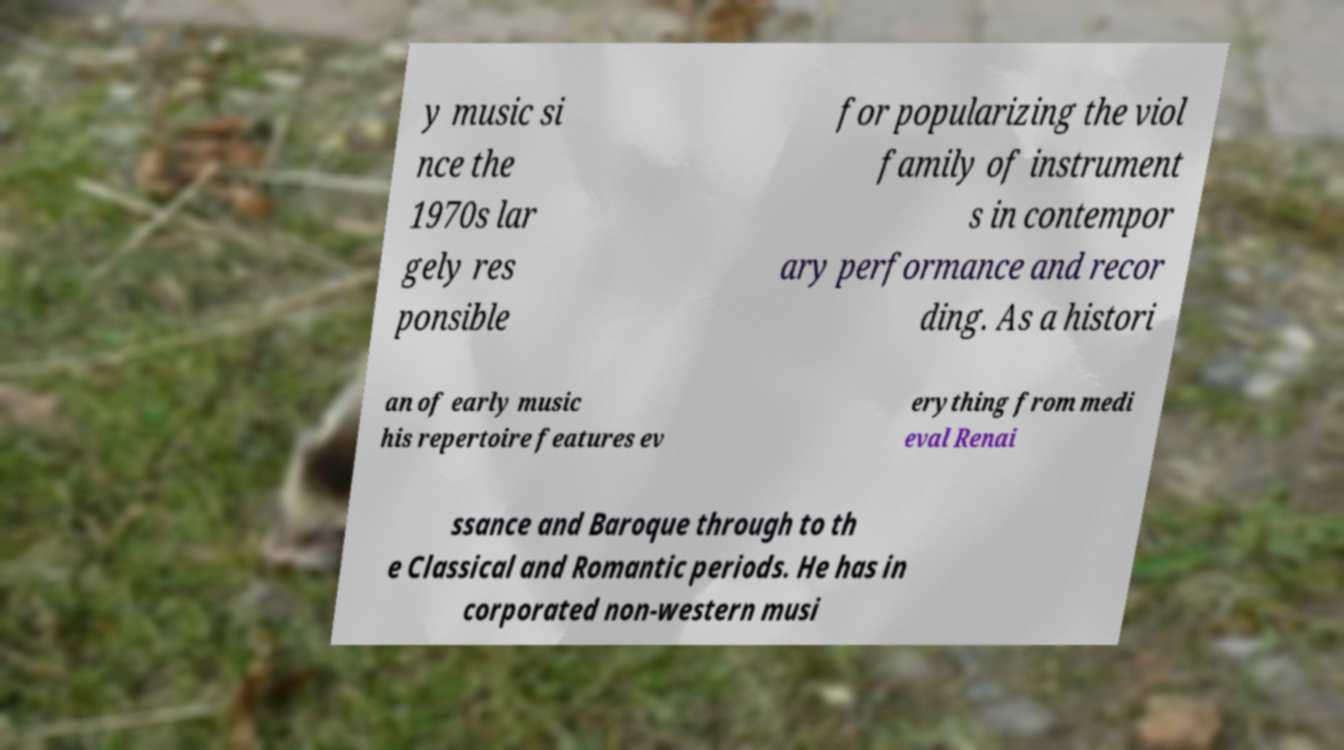Could you assist in decoding the text presented in this image and type it out clearly? y music si nce the 1970s lar gely res ponsible for popularizing the viol family of instrument s in contempor ary performance and recor ding. As a histori an of early music his repertoire features ev erything from medi eval Renai ssance and Baroque through to th e Classical and Romantic periods. He has in corporated non-western musi 